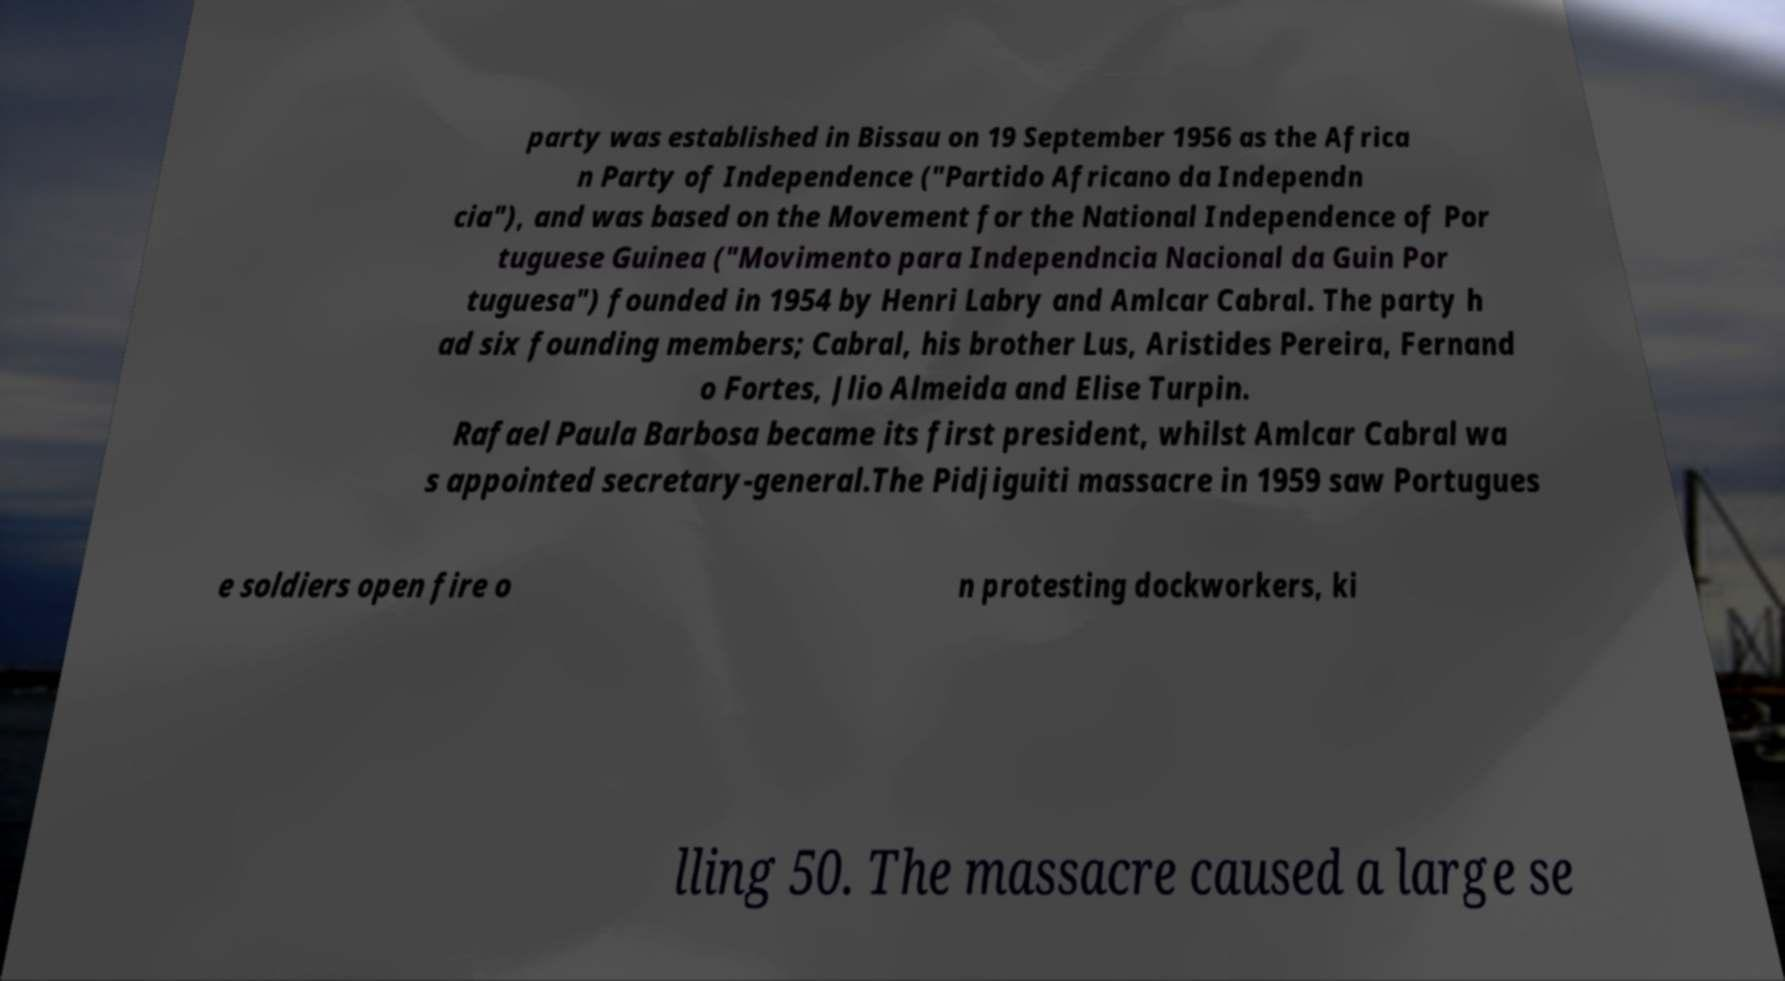Can you accurately transcribe the text from the provided image for me? party was established in Bissau on 19 September 1956 as the Africa n Party of Independence ("Partido Africano da Independn cia"), and was based on the Movement for the National Independence of Por tuguese Guinea ("Movimento para Independncia Nacional da Guin Por tuguesa") founded in 1954 by Henri Labry and Amlcar Cabral. The party h ad six founding members; Cabral, his brother Lus, Aristides Pereira, Fernand o Fortes, Jlio Almeida and Elise Turpin. Rafael Paula Barbosa became its first president, whilst Amlcar Cabral wa s appointed secretary-general.The Pidjiguiti massacre in 1959 saw Portugues e soldiers open fire o n protesting dockworkers, ki lling 50. The massacre caused a large se 